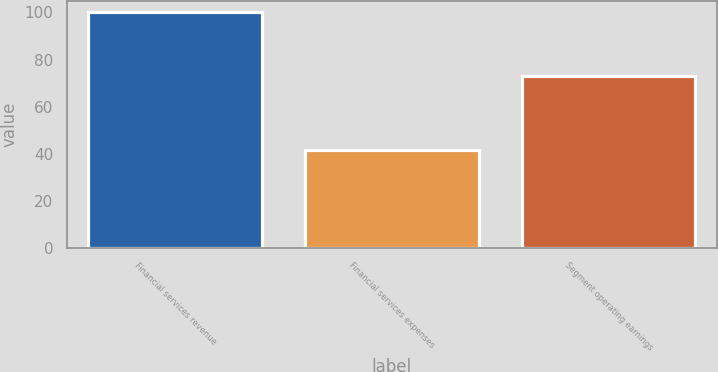Convert chart to OTSL. <chart><loc_0><loc_0><loc_500><loc_500><bar_chart><fcel>Financial services revenue<fcel>Financial services expenses<fcel>Segment operating earnings<nl><fcel>100<fcel>41.4<fcel>73.1<nl></chart> 